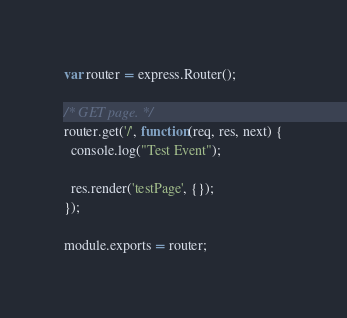<code> <loc_0><loc_0><loc_500><loc_500><_JavaScript_>var router = express.Router();

/* GET page. */
router.get('/', function(req, res, next) {
  console.log("Test Event");  

  res.render('testPage', {});
});

module.exports = router;
</code> 